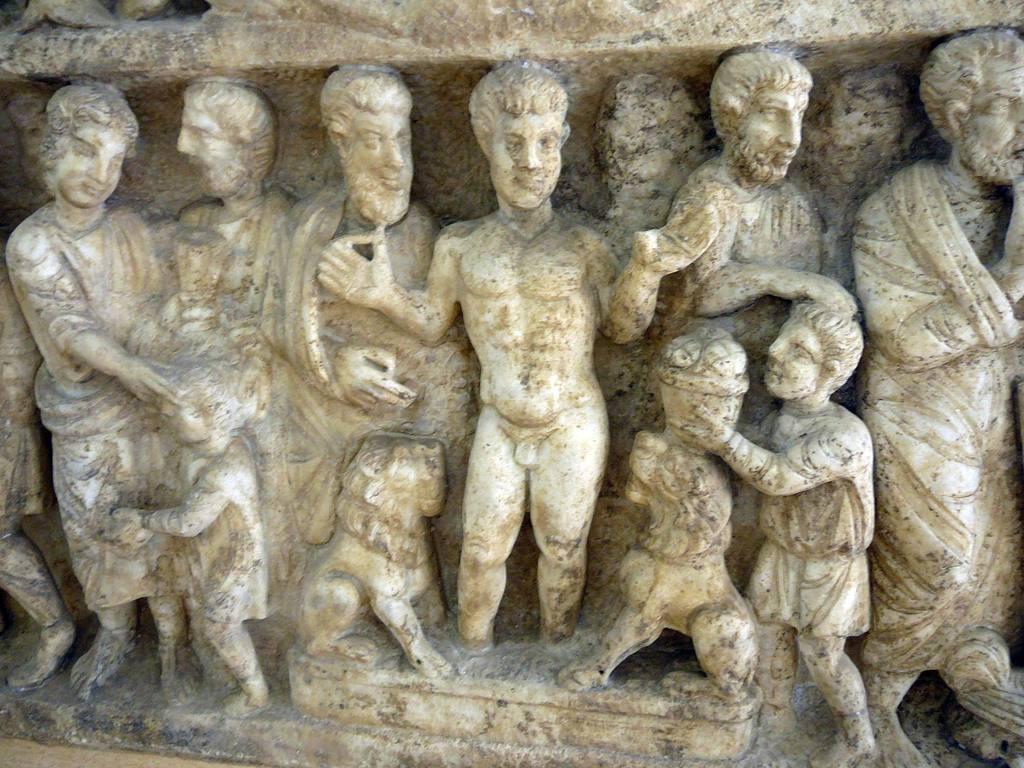How would you summarize this image in a sentence or two? In this image we can see some sculptures on the wall. 